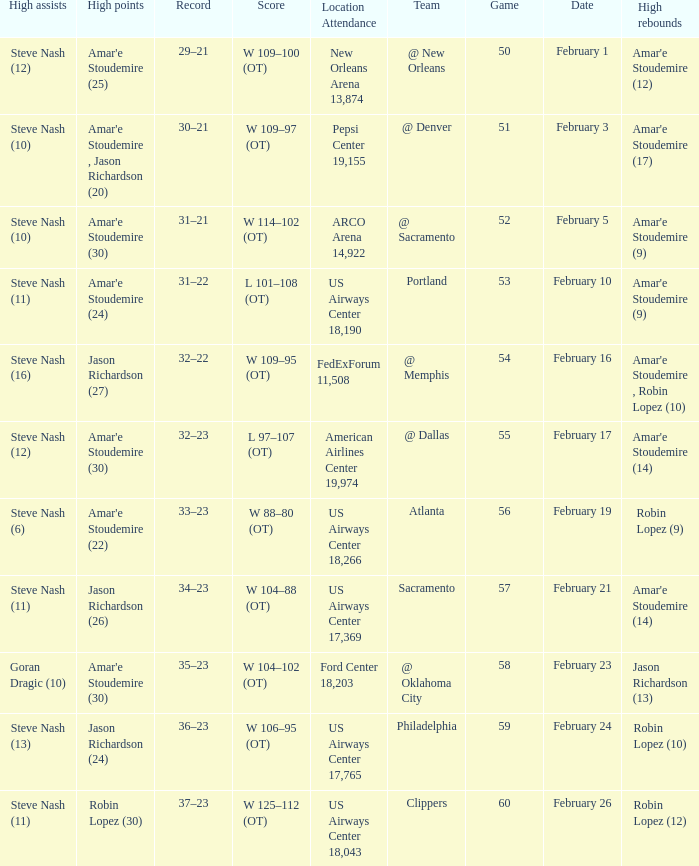Name the date for score w 109–95 (ot) February 16. 